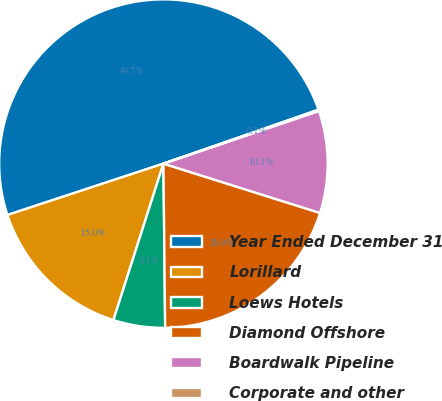Convert chart. <chart><loc_0><loc_0><loc_500><loc_500><pie_chart><fcel>Year Ended December 31<fcel>Lorillard<fcel>Loews Hotels<fcel>Diamond Offshore<fcel>Boardwalk Pipeline<fcel>Corporate and other<nl><fcel>49.73%<fcel>15.01%<fcel>5.09%<fcel>19.97%<fcel>10.05%<fcel>0.13%<nl></chart> 